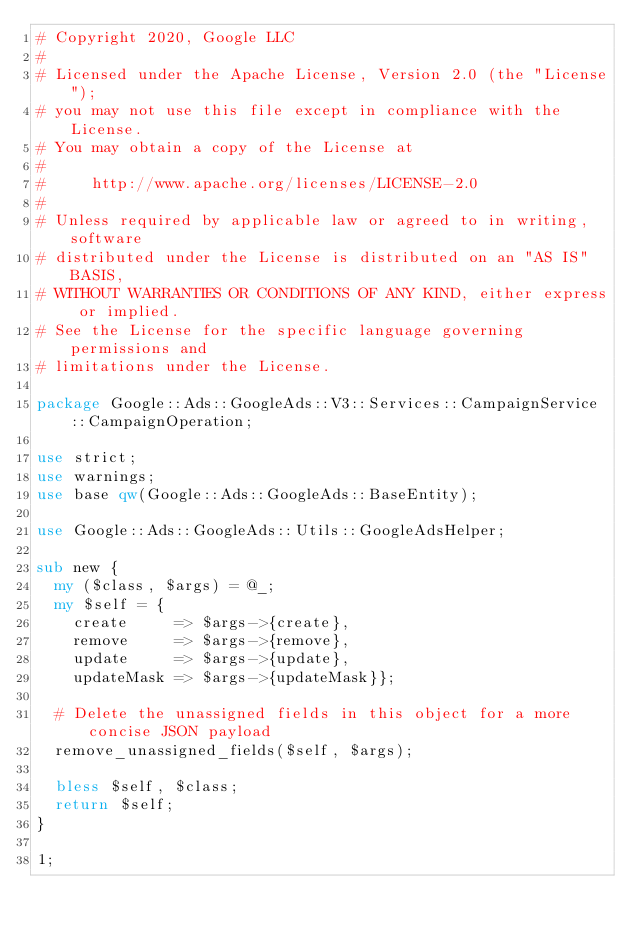<code> <loc_0><loc_0><loc_500><loc_500><_Perl_># Copyright 2020, Google LLC
#
# Licensed under the Apache License, Version 2.0 (the "License");
# you may not use this file except in compliance with the License.
# You may obtain a copy of the License at
#
#     http://www.apache.org/licenses/LICENSE-2.0
#
# Unless required by applicable law or agreed to in writing, software
# distributed under the License is distributed on an "AS IS" BASIS,
# WITHOUT WARRANTIES OR CONDITIONS OF ANY KIND, either express or implied.
# See the License for the specific language governing permissions and
# limitations under the License.

package Google::Ads::GoogleAds::V3::Services::CampaignService::CampaignOperation;

use strict;
use warnings;
use base qw(Google::Ads::GoogleAds::BaseEntity);

use Google::Ads::GoogleAds::Utils::GoogleAdsHelper;

sub new {
  my ($class, $args) = @_;
  my $self = {
    create     => $args->{create},
    remove     => $args->{remove},
    update     => $args->{update},
    updateMask => $args->{updateMask}};

  # Delete the unassigned fields in this object for a more concise JSON payload
  remove_unassigned_fields($self, $args);

  bless $self, $class;
  return $self;
}

1;
</code> 